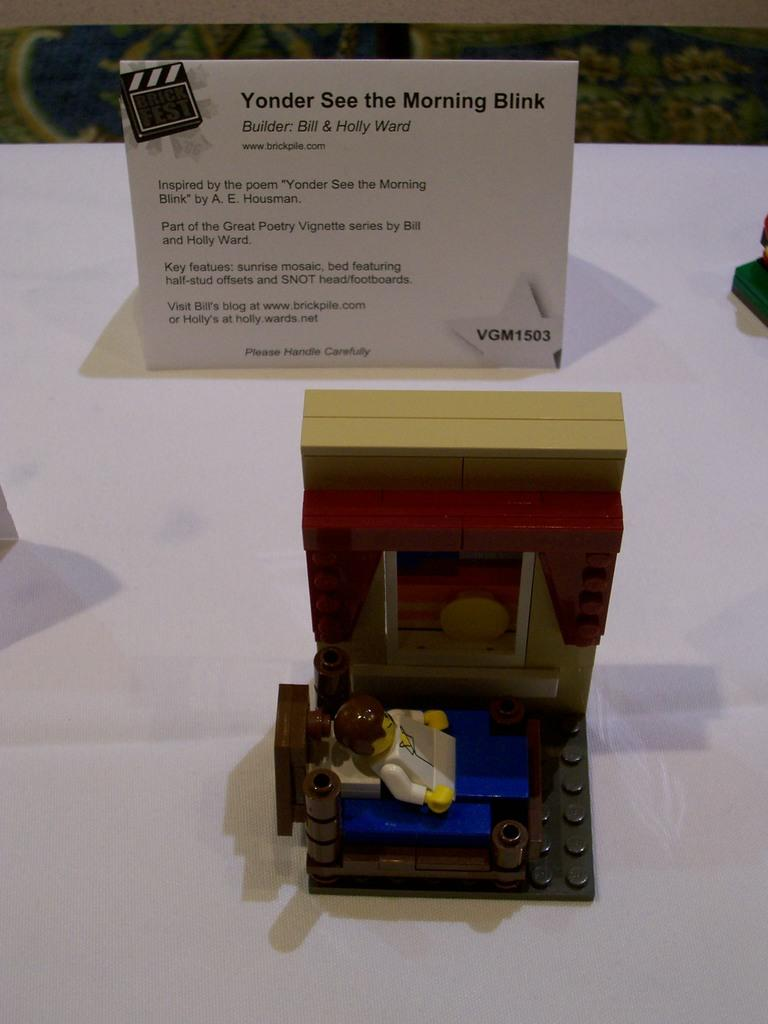Provide a one-sentence caption for the provided image. Lego creation of a person in bed named "Yonder See the Morning Blink". 